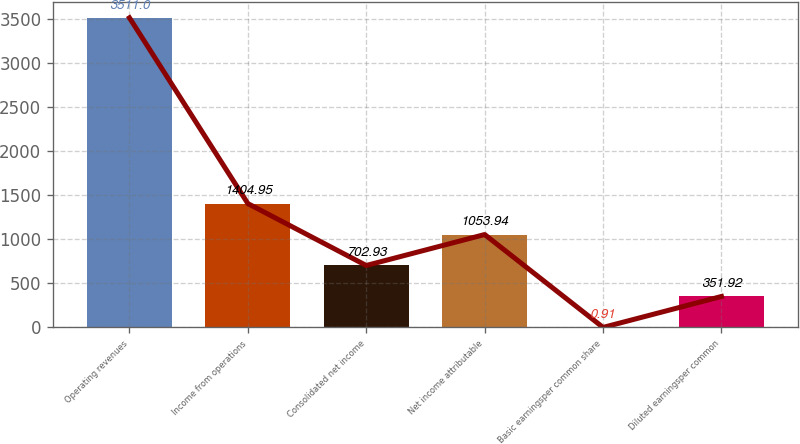<chart> <loc_0><loc_0><loc_500><loc_500><bar_chart><fcel>Operating revenues<fcel>Income from operations<fcel>Consolidated net income<fcel>Net income attributable<fcel>Basic earningsper common share<fcel>Diluted earningsper common<nl><fcel>3511<fcel>1404.95<fcel>702.93<fcel>1053.94<fcel>0.91<fcel>351.92<nl></chart> 